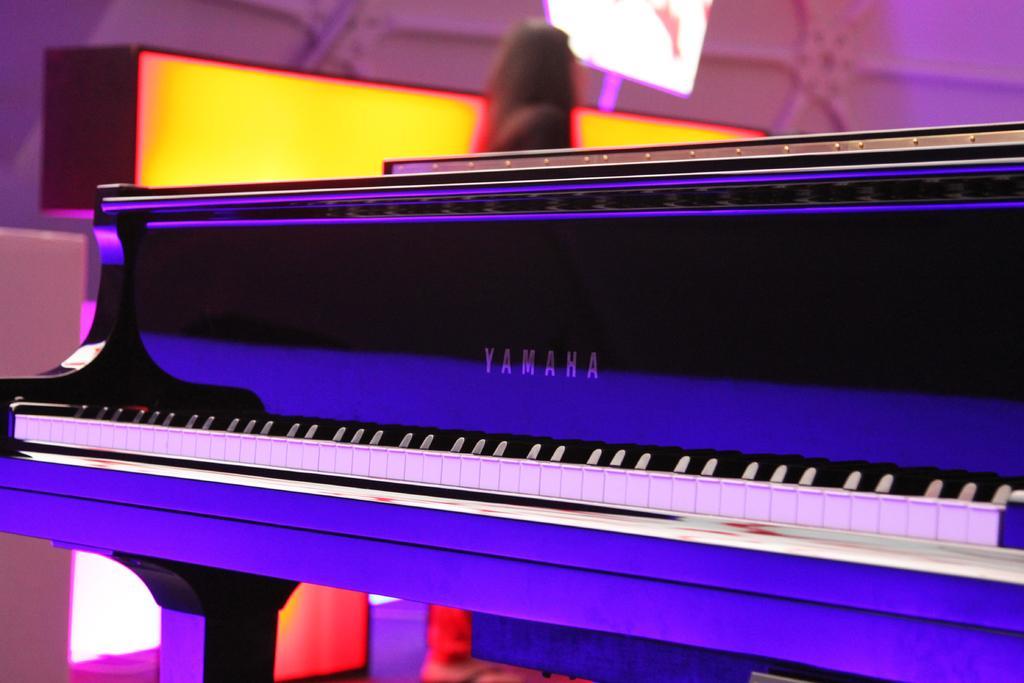How would you summarize this image in a sentence or two? In this picture, there is a piano kept on the table. In the middle of the image, there is one person. In the background, there is a board white in color. In the image, there is a light yellow in color. The background is pink in color. It looks as if the picture is taken inside the hall. 